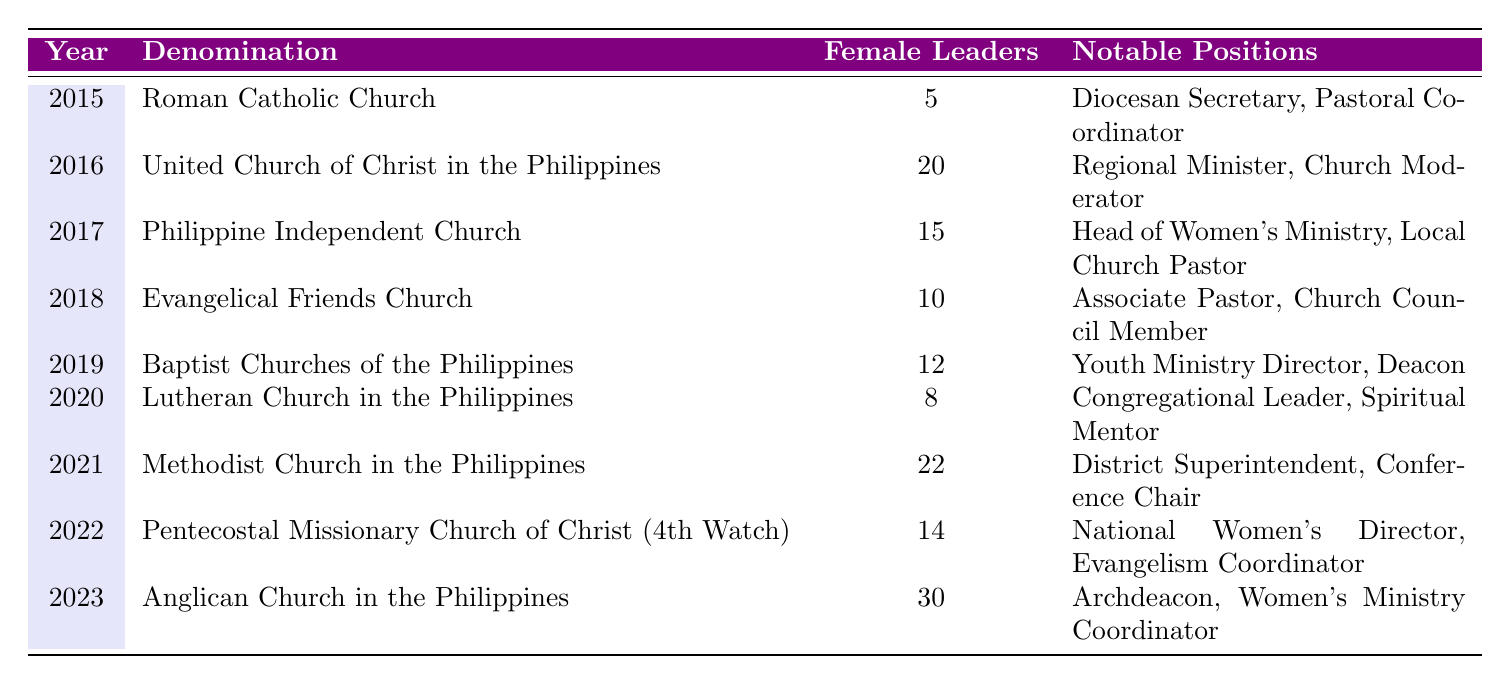What was the highest number of female leaders in a denomination from 2015 to 2023? In the table, the highest number of female leaders is 30, which occurred in the year 2023 in the Anglican Church in the Philippines.
Answer: 30 Which denomination had the least female leaders in 2020? According to the table, the Lutheran Church in the Philippines had the least female leaders in 2020, with a total of 8 female leaders.
Answer: Lutheran Church in the Philippines What is the total number of female leaders across all denominations in 2019? From the table, the only record for 2019 is for the Baptist Churches of the Philippines which had 12 female leaders. There are no other entries, so the total is 12.
Answer: 12 Was there an increase in the number of female leaders from 2015 to 2023? By comparing the values, in 2015 there were 5 female leaders, and in 2023 there are 30. Since 30 is greater than 5, it confirms there was indeed an increase in female leaders from 2015 to 2023.
Answer: Yes What is the average number of female leaders across all years listed in the table? To calculate the average, first sum the number of female leaders: 5 + 20 + 15 + 10 + 12 + 8 + 22 + 14 + 30 = 136. Then, divide by the number of years, which is 9. Therefore, the average is 136 / 9, approximately 15.11.
Answer: 15.11 Which year had a notable position of "Archdeacon"? The notable position of "Archdeacon" is listed under the Anglican Church in the Philippines for the year 2023.
Answer: 2023 How many denominations had more than 15 female leaders in any year? Analyzing the table, the denominations with more than 15 female leaders are the United Church of Christ in the Philippines (2016), Methodist Church in the Philippines (2021), and Anglican Church in the Philippines (2023). This totals to 3 denominations.
Answer: 3 Did the number of female leaders in the Roman Catholic Church increase from 2015 to 2021? In 2015, the Roman Catholic Church had 5 female leaders, while in 2021 there is no data specifically provided for them for that year, but as the years progressed, denominations such as the Methodist Church seemed to gain more. Since Roman Catholic Church's data is missing for the years in between, we cannot definitively say if it increased without that information.
Answer: No 